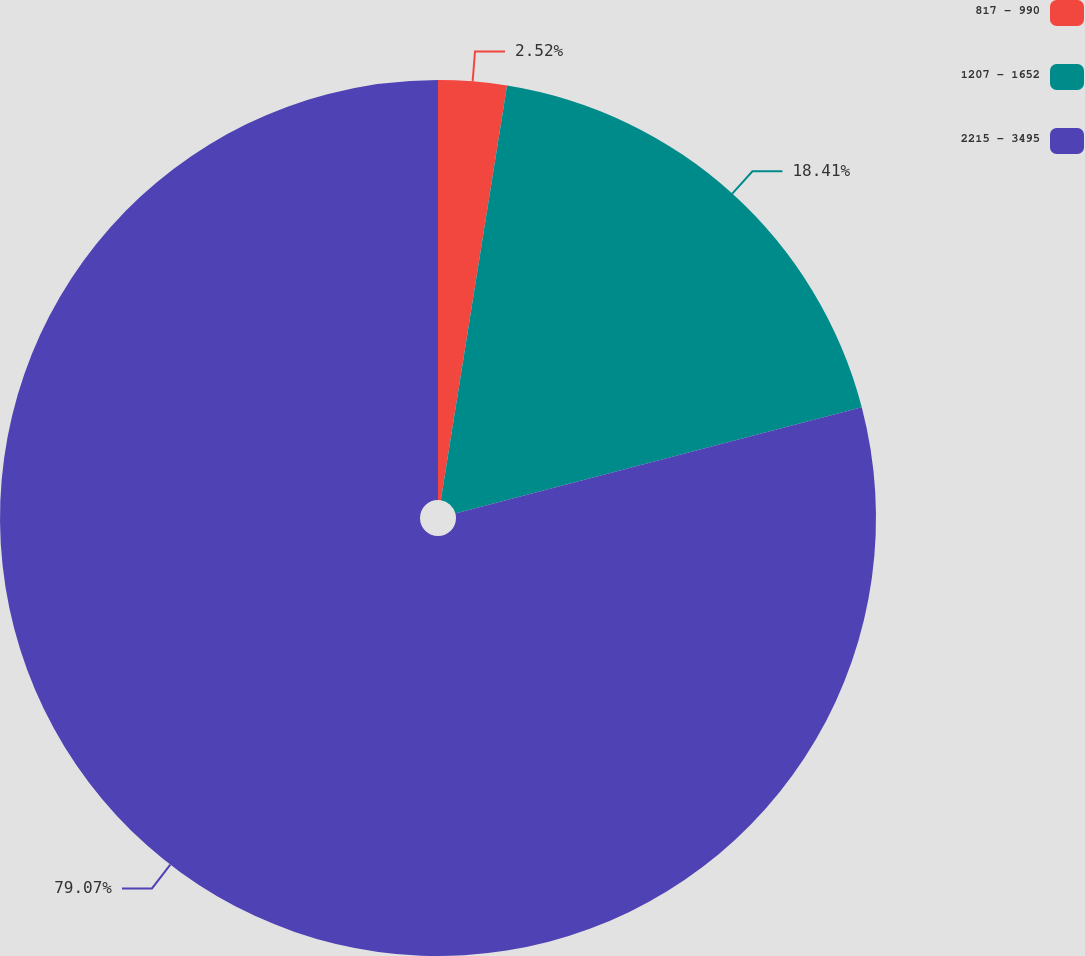<chart> <loc_0><loc_0><loc_500><loc_500><pie_chart><fcel>817 - 990<fcel>1207 - 1652<fcel>2215 - 3495<nl><fcel>2.52%<fcel>18.41%<fcel>79.07%<nl></chart> 